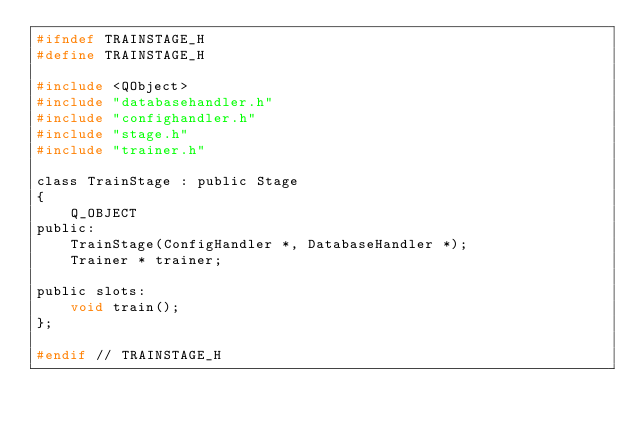Convert code to text. <code><loc_0><loc_0><loc_500><loc_500><_C_>#ifndef TRAINSTAGE_H
#define TRAINSTAGE_H

#include <QObject>
#include "databasehandler.h"
#include "confighandler.h"
#include "stage.h"
#include "trainer.h"

class TrainStage : public Stage
{
    Q_OBJECT
public:
    TrainStage(ConfigHandler *, DatabaseHandler *);
    Trainer * trainer;

public slots:
    void train();
};

#endif // TRAINSTAGE_H
</code> 